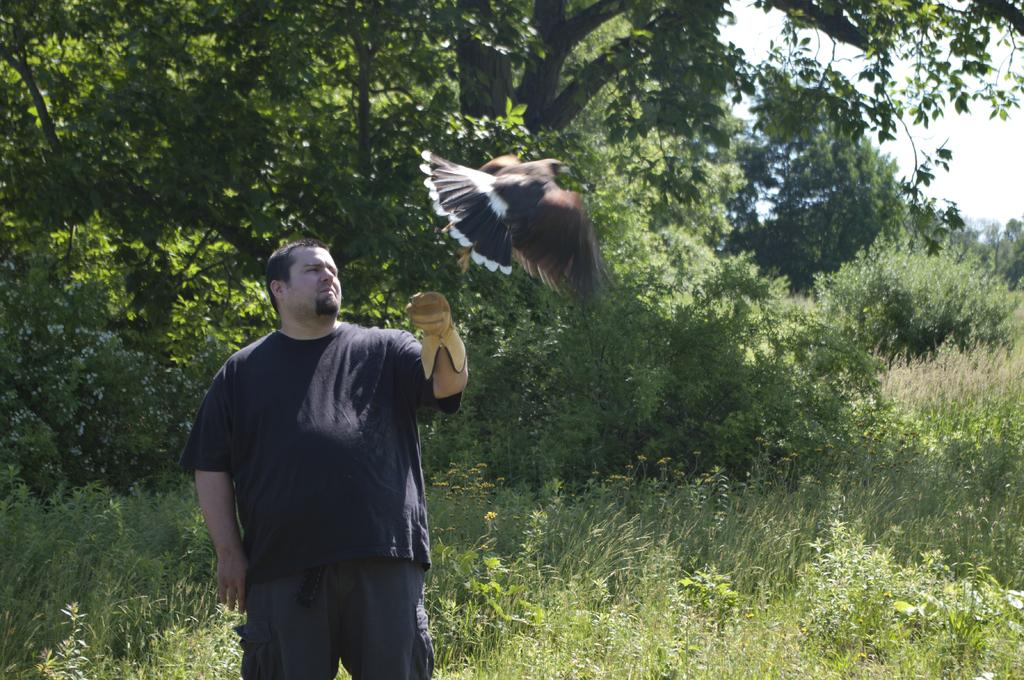Who is present in the image? There is a man in the image. What is the man wearing on his hand? The man is wearing a glove. What is flying in the image? There is an eagle flying in the image. What type of vegetation can be seen behind the man? There are trees behind the man. What is the ground covered with in the image? There is grass in the image. What part of the sky is visible in the image? The sky is visible in the top right corner of the image. Where is the shop located in the image? There is no shop present in the image. What type of division can be seen between the man and the eagle in the image? There is no division between the man and the eagle in the image; they are not interacting or separated by any object or space. 